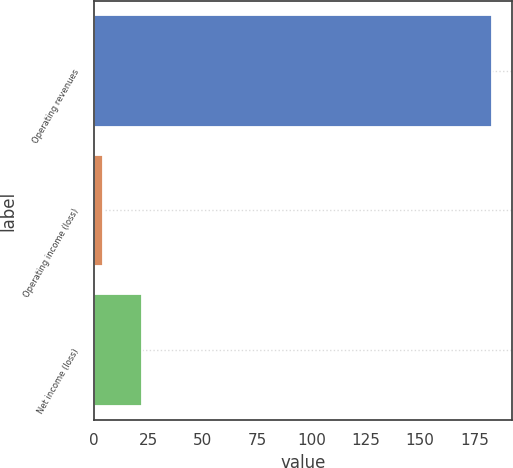Convert chart. <chart><loc_0><loc_0><loc_500><loc_500><bar_chart><fcel>Operating revenues<fcel>Operating income (loss)<fcel>Net income (loss)<nl><fcel>183<fcel>4<fcel>21.9<nl></chart> 